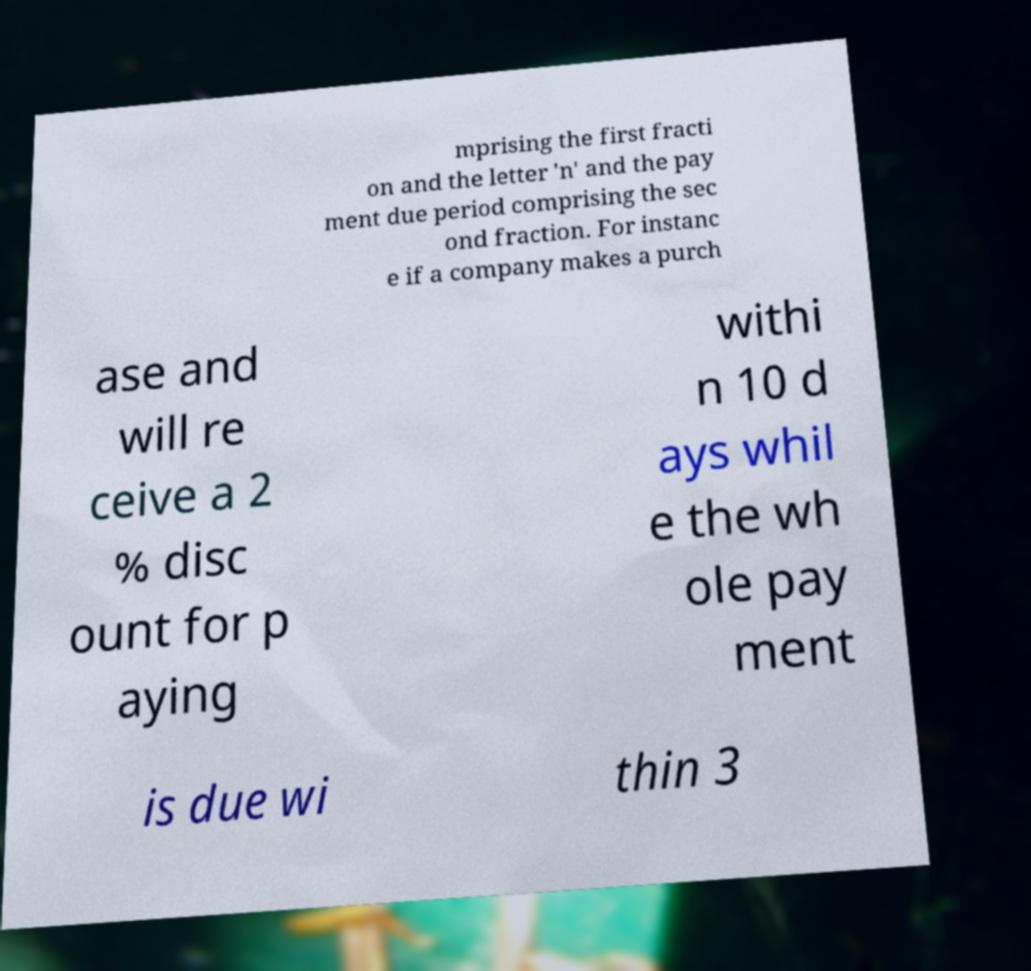Could you extract and type out the text from this image? mprising the first fracti on and the letter 'n' and the pay ment due period comprising the sec ond fraction. For instanc e if a company makes a purch ase and will re ceive a 2 % disc ount for p aying withi n 10 d ays whil e the wh ole pay ment is due wi thin 3 